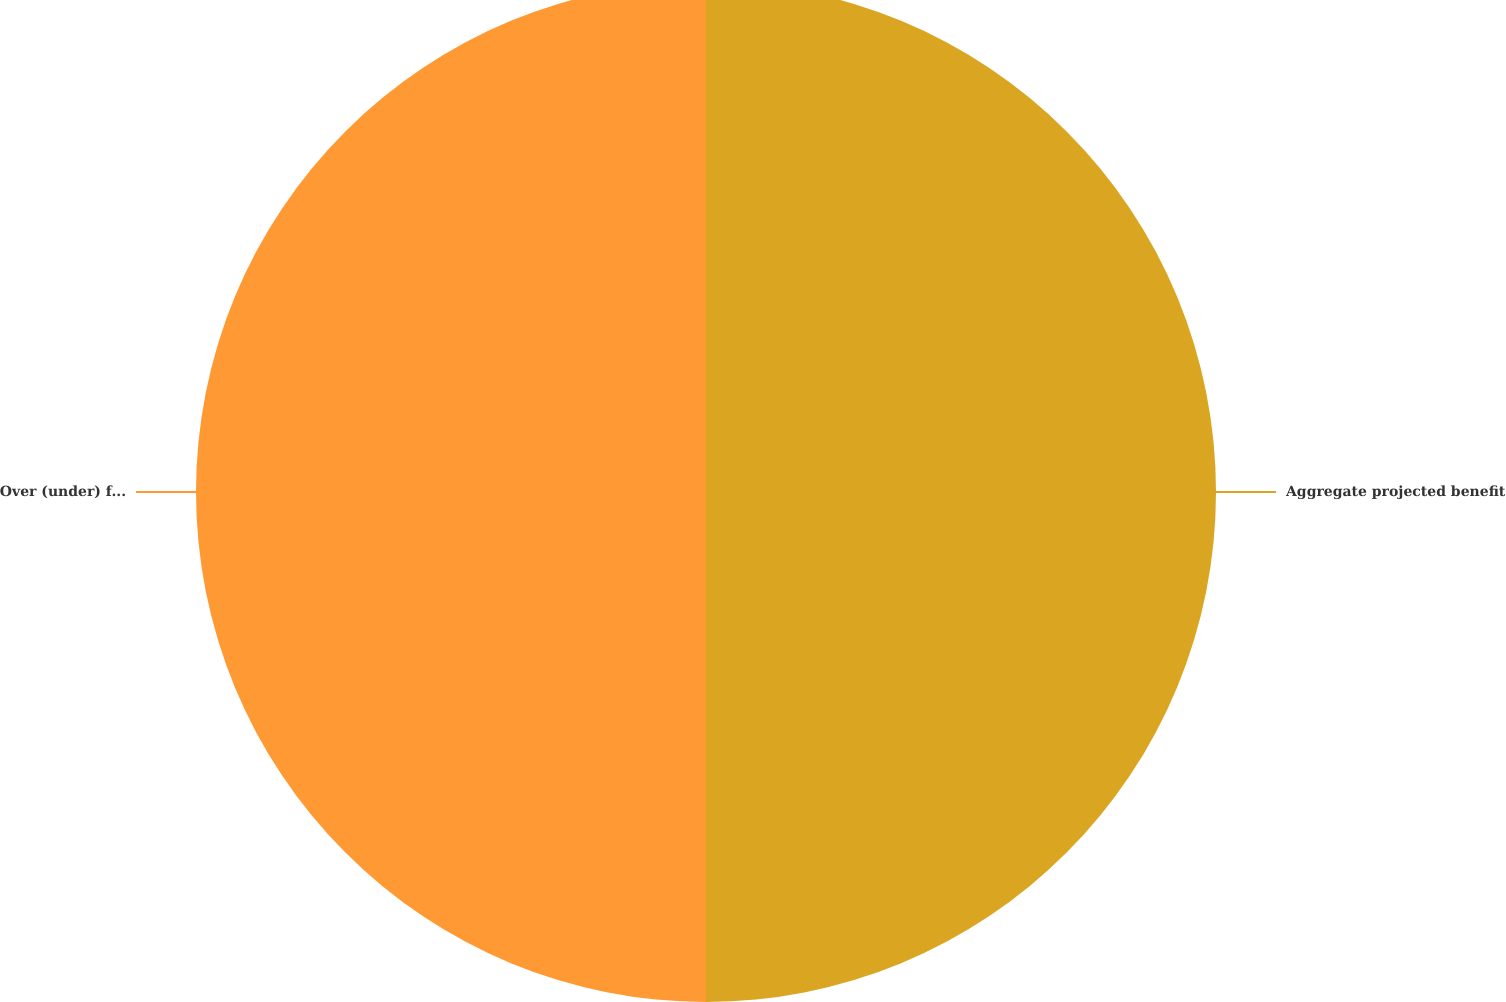<chart> <loc_0><loc_0><loc_500><loc_500><pie_chart><fcel>Aggregate projected benefit<fcel>Over (under) funded<nl><fcel>50.0%<fcel>50.0%<nl></chart> 